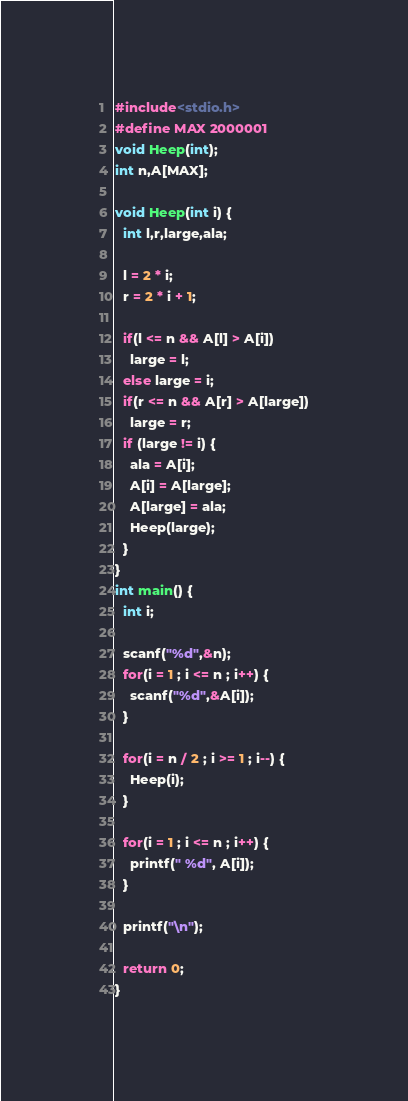<code> <loc_0><loc_0><loc_500><loc_500><_C_>#include<stdio.h>
#define MAX 2000001
void Heep(int);
int n,A[MAX];

void Heep(int i) {
  int l,r,large,ala;

  l = 2 * i;
  r = 2 * i + 1;

  if(l <= n && A[l] > A[i])
    large = l;
  else large = i;
  if(r <= n && A[r] > A[large])
    large = r;
  if (large != i) {
    ala = A[i];
    A[i] = A[large];
    A[large] = ala;
    Heep(large);
  }
}
int main() {
  int i;

  scanf("%d",&n);
  for(i = 1 ; i <= n ; i++) {
    scanf("%d",&A[i]);
  }
  
  for(i = n / 2 ; i >= 1 ; i--) {
    Heep(i);
  }
  
  for(i = 1 ; i <= n ; i++) {
    printf(" %d", A[i]);
  }
  
  printf("\n");
  
  return 0;
}


</code> 